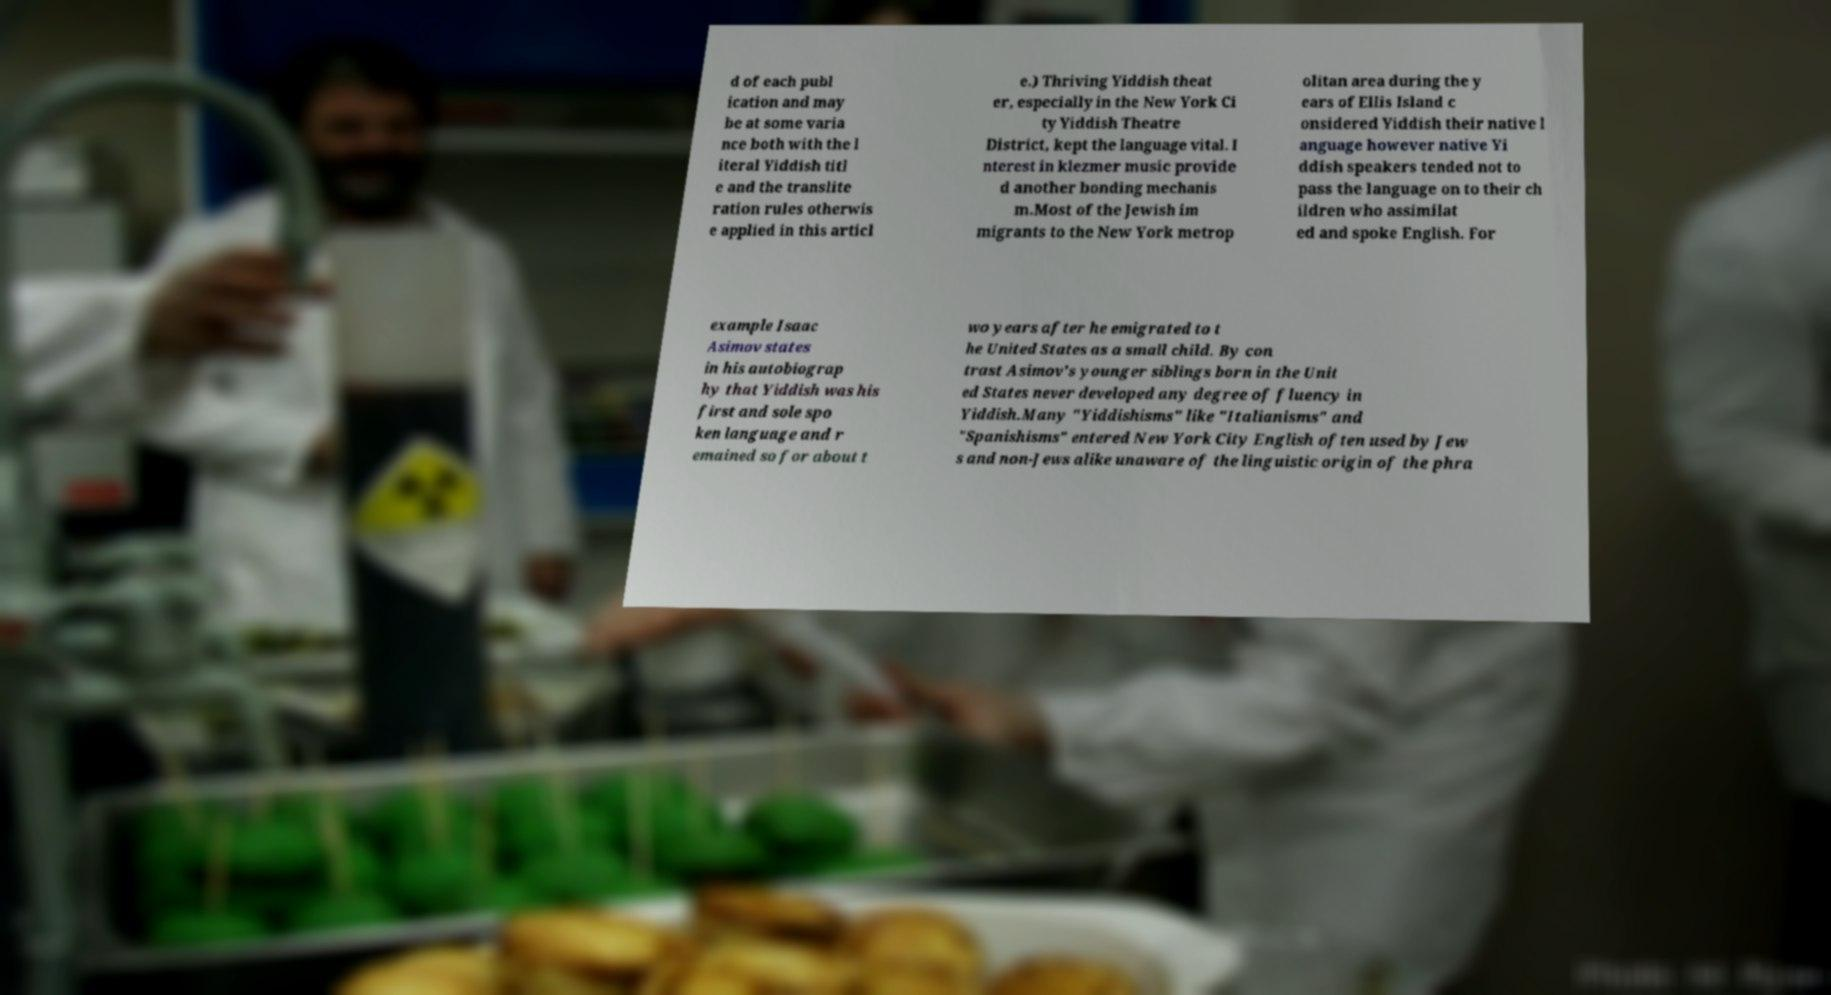Could you extract and type out the text from this image? d of each publ ication and may be at some varia nce both with the l iteral Yiddish titl e and the translite ration rules otherwis e applied in this articl e.) Thriving Yiddish theat er, especially in the New York Ci ty Yiddish Theatre District, kept the language vital. I nterest in klezmer music provide d another bonding mechanis m.Most of the Jewish im migrants to the New York metrop olitan area during the y ears of Ellis Island c onsidered Yiddish their native l anguage however native Yi ddish speakers tended not to pass the language on to their ch ildren who assimilat ed and spoke English. For example Isaac Asimov states in his autobiograp hy that Yiddish was his first and sole spo ken language and r emained so for about t wo years after he emigrated to t he United States as a small child. By con trast Asimov's younger siblings born in the Unit ed States never developed any degree of fluency in Yiddish.Many "Yiddishisms" like "Italianisms" and "Spanishisms" entered New York City English often used by Jew s and non-Jews alike unaware of the linguistic origin of the phra 